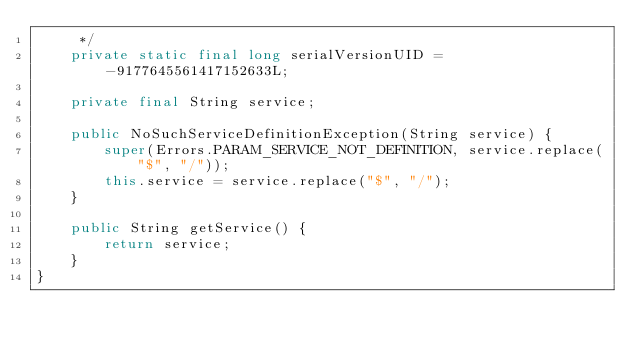Convert code to text. <code><loc_0><loc_0><loc_500><loc_500><_Java_>	 */
	private static final long serialVersionUID = -9177645561417152633L;
	
	private final String service;
	
	public NoSuchServiceDefinitionException(String service) {
		super(Errors.PARAM_SERVICE_NOT_DEFINITION, service.replace("$", "/"));
		this.service = service.replace("$", "/");
	}

	public String getService() {
		return service;
	}
}
</code> 